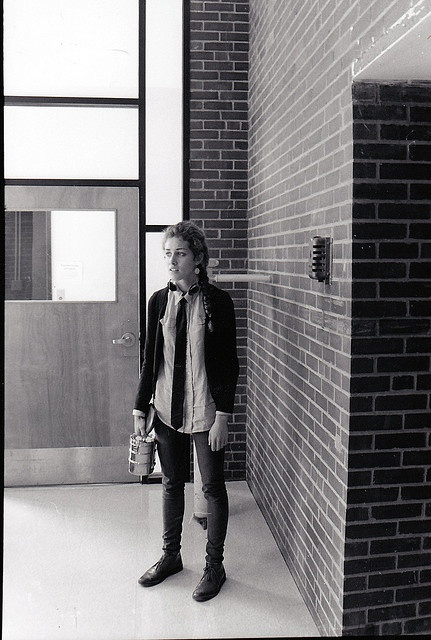Describe the objects in this image and their specific colors. I can see people in black, darkgray, gray, and lightgray tones and tie in black and gray tones in this image. 